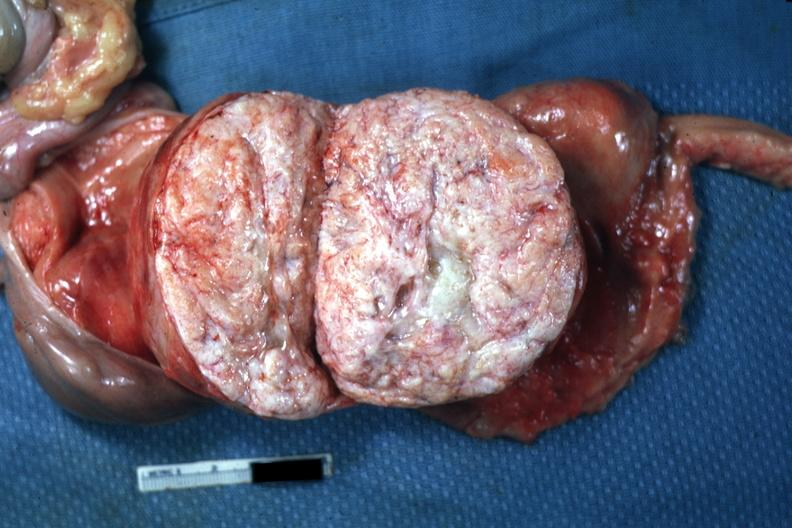has mesothelioma been sliced open like book can not readily see uterus itself myoma lesion is quite typical close-up photo?
Answer the question using a single word or phrase. No 